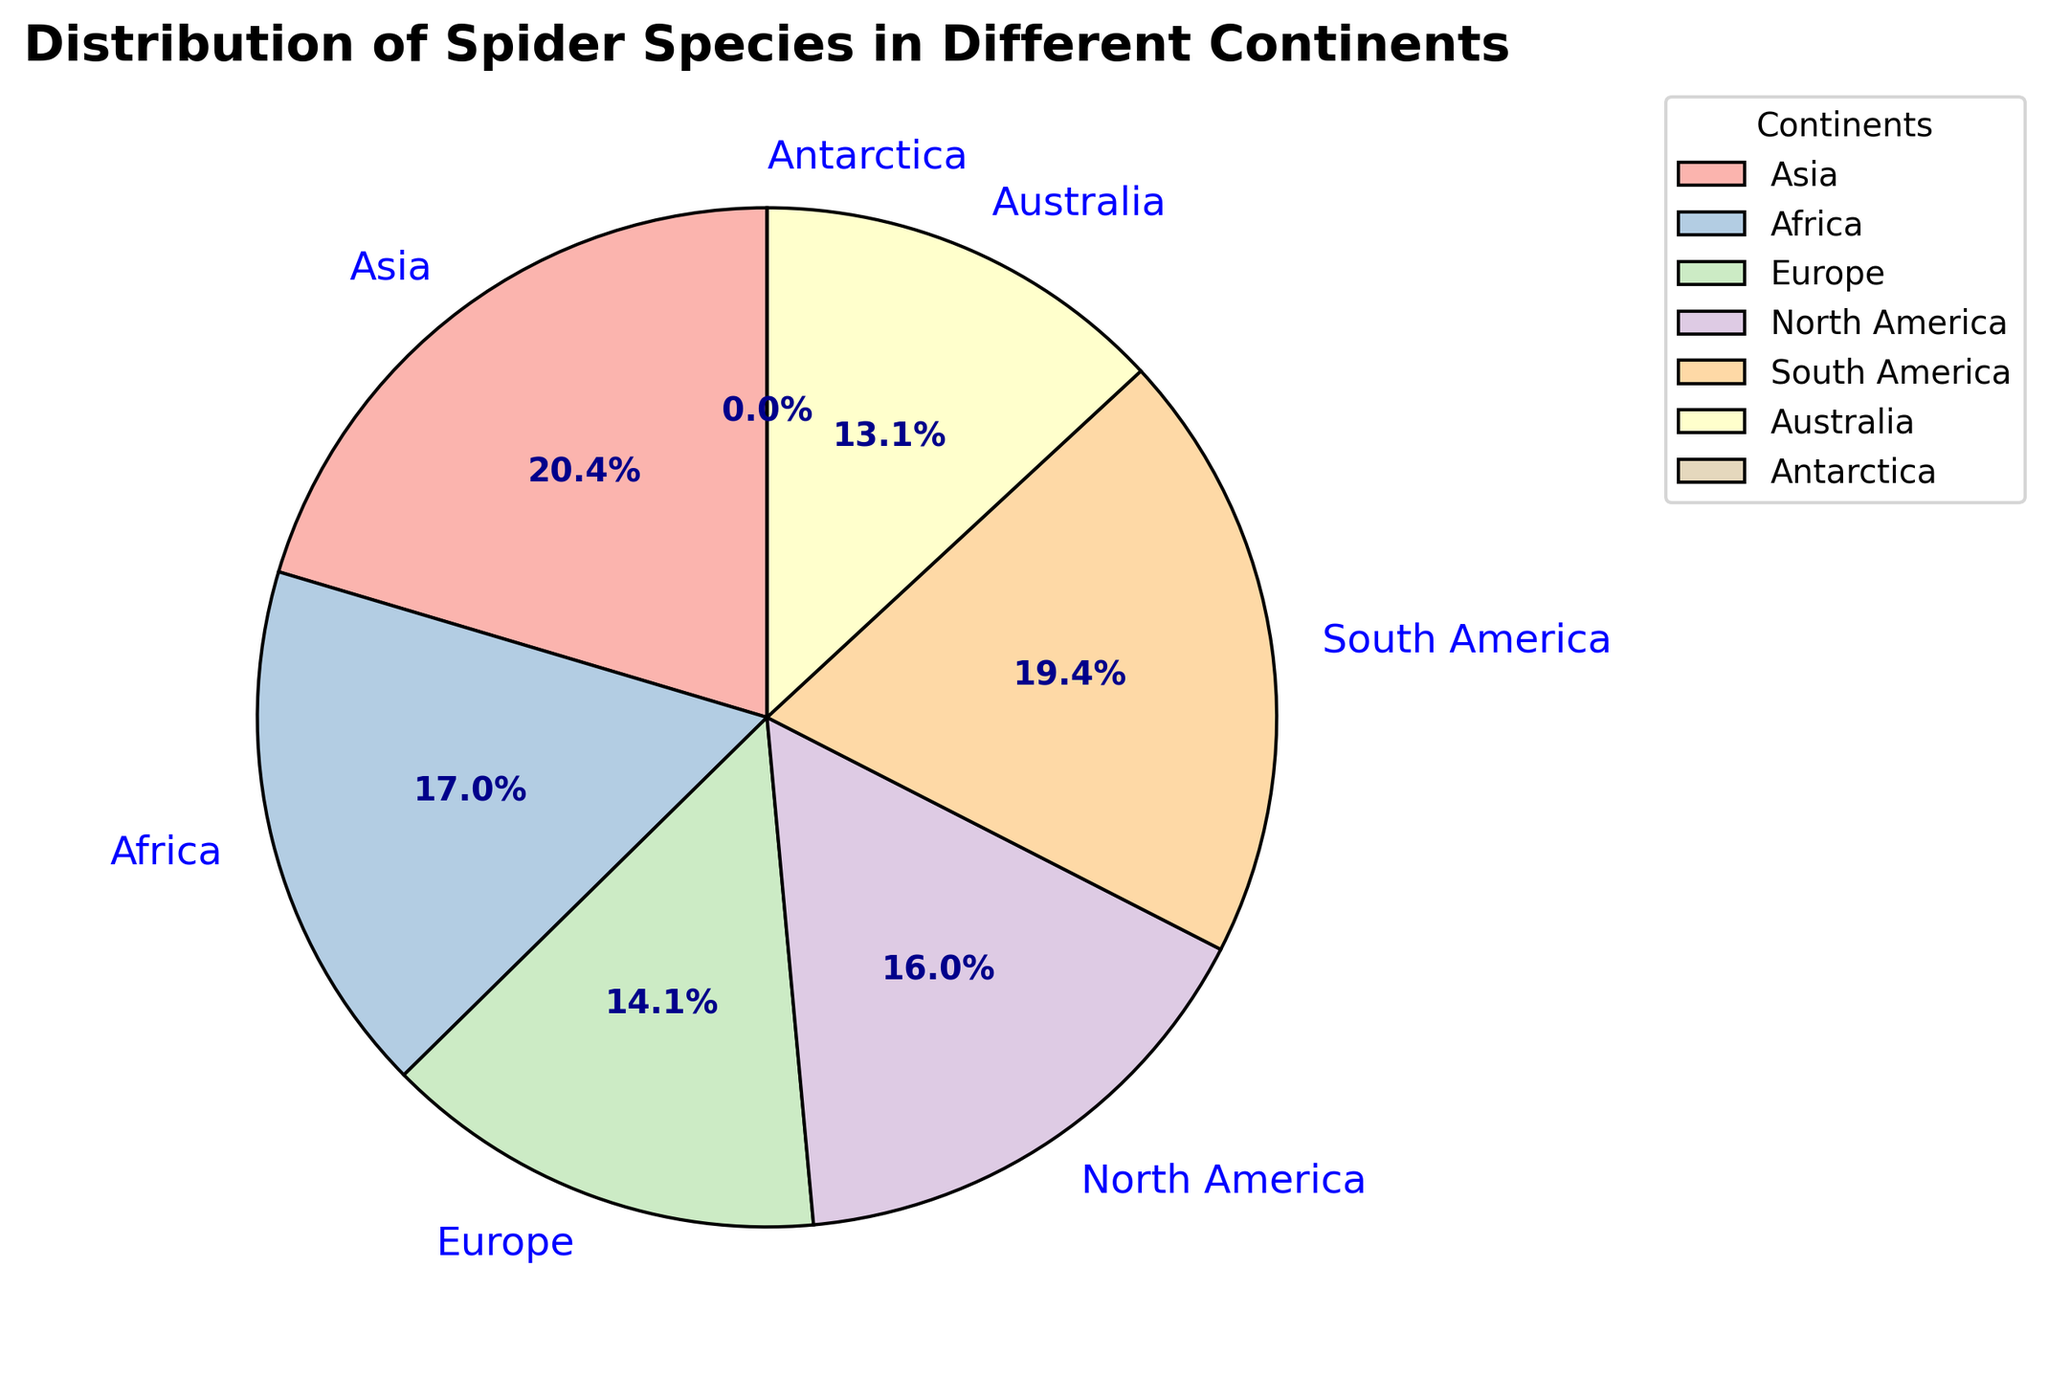What percentage of spider species are found in Asia? By looking at the pie chart, find the slice labeled "Asia" and read the percentage next to it.
Answer: 28.1% Which continent has the smallest number of spider species? Identify the smallest slice in the pie chart and read its label.
Answer: Antarctica How many more species are there in Asia compared to Europe? Look at the species counts for Asia and Europe from the pie chart. Subtract the number of species in Europe from the number of species in Asia (4200 - 2900).
Answer: 1300 What's the combined percentage of spider species in North America and South America? Add the percentage values for North America and South America from the pie chart. For example, if North America has 22.2% and South America has 27.3%, then the combined percentage is 22.2% + 27.3%.
Answer: 21.4% + 25.8% = 47.2% Are there more spider species in Africa or Australia? Compare the size of the slices for Africa and Australia and their associated species counts.
Answer: Africa What is the ratio of spider species between South America and Australia? First, find the species counts for South America and Australia from the pie chart (4000 and 2700 respectively). Then, divide the count for South America by the count for Australia (4000 / 2700).
Answer: 1.48 Which three continents have the highest number of spider species, and what are their respective percentages? Identify the three largest slices in the pie chart and read their labels and percentages.
Answer: Asia (28.1%), South America (25.8%), Africa (22.6%) If you sum the percentages of all continents, what do you get? Add up all the percentages shown on the pie chart for each continent: (28.1% + 22.6% + 19.8% + 22.2% + 25.8% + 18.8%)
Answer: 100% Between which two consecutive continents is the smallest difference in spider species count observed? Compare the species count differences between each adjacent pair of continents by inspecting their slices on the pie chart. Find the pair with the smallest difference.
Answer: Europe and Australia (Cancer: 200) What color represents Africa in the pie chart, and what percentage does it cover? Identify the color used for Africa on the pie chart and look at the corresponding percentage label.
Answer: Light Green, 22.6% 